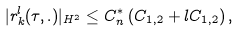<formula> <loc_0><loc_0><loc_500><loc_500>| r ^ { l } _ { k } ( \tau , . ) | _ { H ^ { 2 } } \leq C ^ { * } _ { n } \left ( C _ { 1 , 2 } + l C _ { 1 , 2 } \right ) ,</formula> 